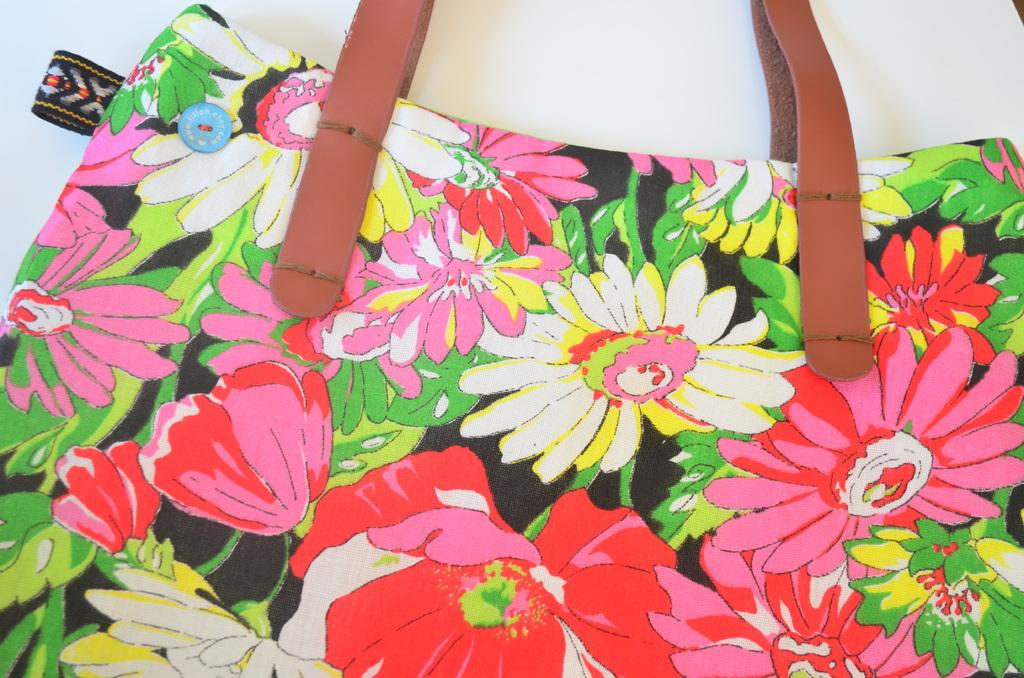What object can be seen in the image? There is a bag in the image. Where is the library located in the image? There is no library present in the image; it only features a bag. What type of club is being used in the image? There is no club present in the image; it only features a bag. 